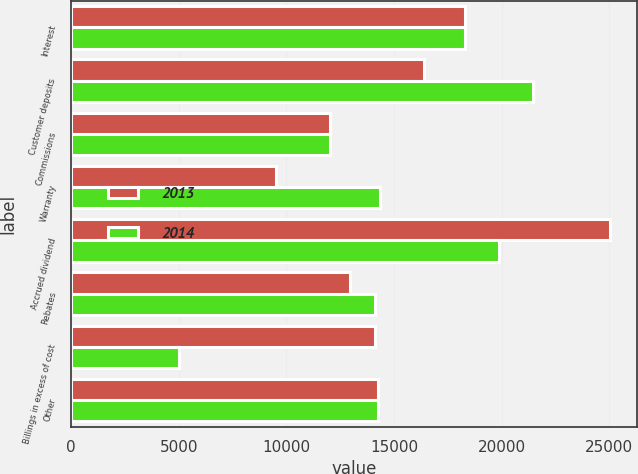Convert chart to OTSL. <chart><loc_0><loc_0><loc_500><loc_500><stacked_bar_chart><ecel><fcel>Interest<fcel>Customer deposits<fcel>Commissions<fcel>Warranty<fcel>Accrued dividend<fcel>Rebates<fcel>Billings in excess of cost<fcel>Other<nl><fcel>2013<fcel>18275<fcel>16392<fcel>12025<fcel>9537<fcel>25032<fcel>12968<fcel>14135<fcel>14235.5<nl><fcel>2014<fcel>18285<fcel>21438<fcel>12030<fcel>14336<fcel>19863<fcel>14104<fcel>5016<fcel>14235.5<nl></chart> 